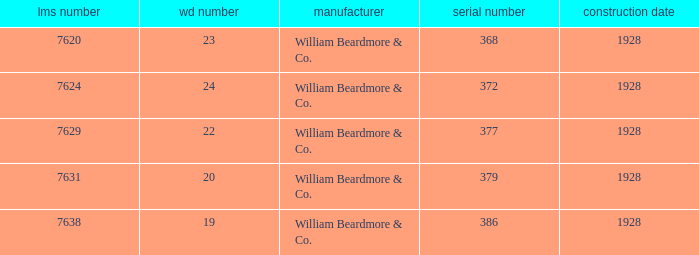Name the lms number for serial number being 372 7624.0. I'm looking to parse the entire table for insights. Could you assist me with that? {'header': ['lms number', 'wd number', 'manufacturer', 'serial number', 'construction date'], 'rows': [['7620', '23', 'William Beardmore & Co.', '368', '1928'], ['7624', '24', 'William Beardmore & Co.', '372', '1928'], ['7629', '22', 'William Beardmore & Co.', '377', '1928'], ['7631', '20', 'William Beardmore & Co.', '379', '1928'], ['7638', '19', 'William Beardmore & Co.', '386', '1928']]} 